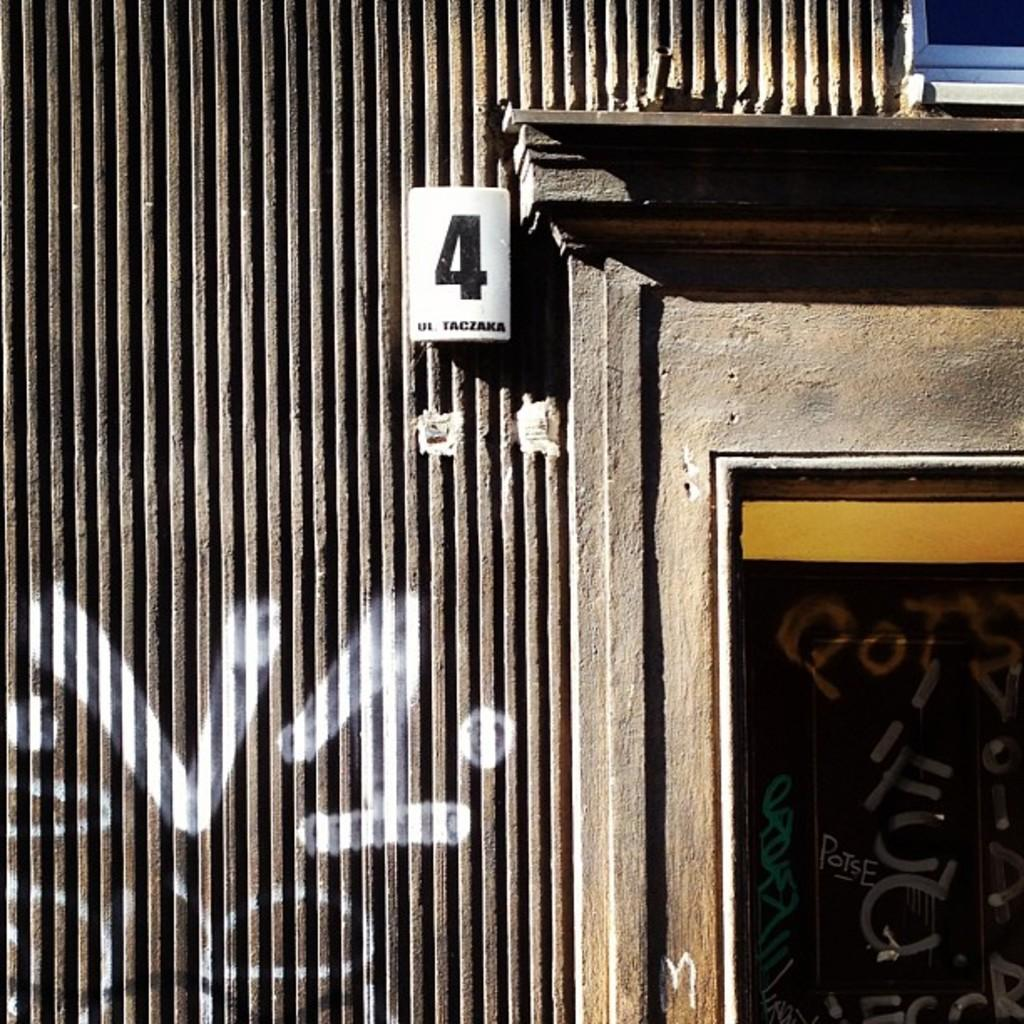What is located in the middle of the image? There is a wall in the middle of the image. What is present at the top of the image? There is a white color board at the top of the image. What can be seen on the white color board? A number is written on the white color board. Is there a baseball game happening in the image? No, there is no baseball game or any reference to sports in the image. What type of tax is being discussed on the white color board? There is no mention of taxes or any financial topic in the image; it only features a wall and a white color board with a number. 